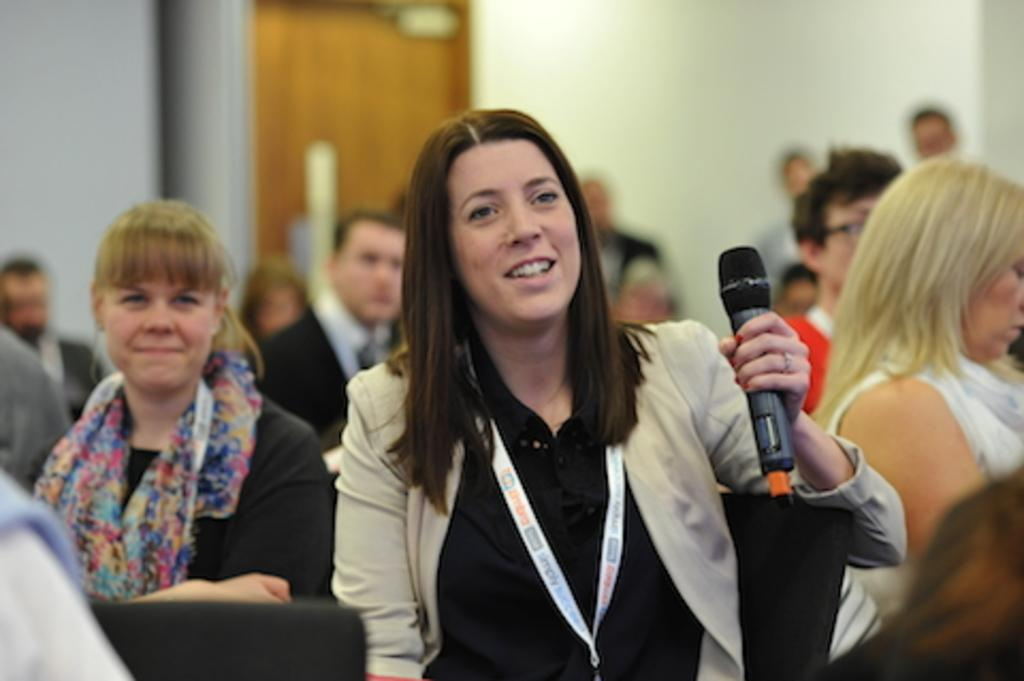What are the people in the image doing? There are people seated and standing in the image. Can you describe the woman holding a microphone? The woman appears to be wearing an ID card. What is visible in the background of the image? There is a door visible in the background of the image. What type of caption can be seen on the woman's bike in the image? There is no bike present in the image, so there is no caption to be seen. 